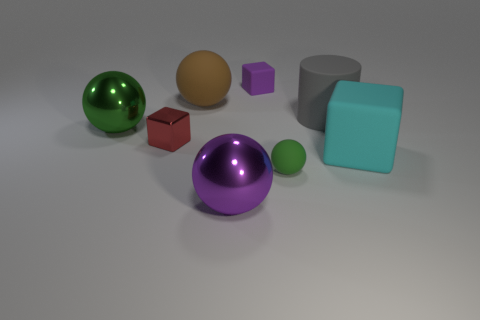How many other objects are there of the same color as the tiny matte sphere?
Provide a short and direct response. 1. Is the shape of the large shiny thing that is in front of the big green thing the same as  the tiny red metal object?
Provide a succinct answer. No. Do the large block and the small rubber block have the same color?
Make the answer very short. No. How many objects are either things that are right of the large green metal object or metal objects?
Keep it short and to the point. 8. What is the shape of the purple thing that is the same size as the green metallic sphere?
Keep it short and to the point. Sphere. Does the green thing on the right side of the big brown matte object have the same size as the purple thing to the right of the large purple sphere?
Your answer should be compact. Yes. There is a tiny sphere that is the same material as the gray cylinder; what is its color?
Offer a terse response. Green. Do the thing that is in front of the tiny green matte object and the green sphere to the right of the large green metal ball have the same material?
Make the answer very short. No. Are there any gray things that have the same size as the metal block?
Offer a terse response. No. There is a rubber sphere behind the tiny rubber thing in front of the large cube; how big is it?
Give a very brief answer. Large. 